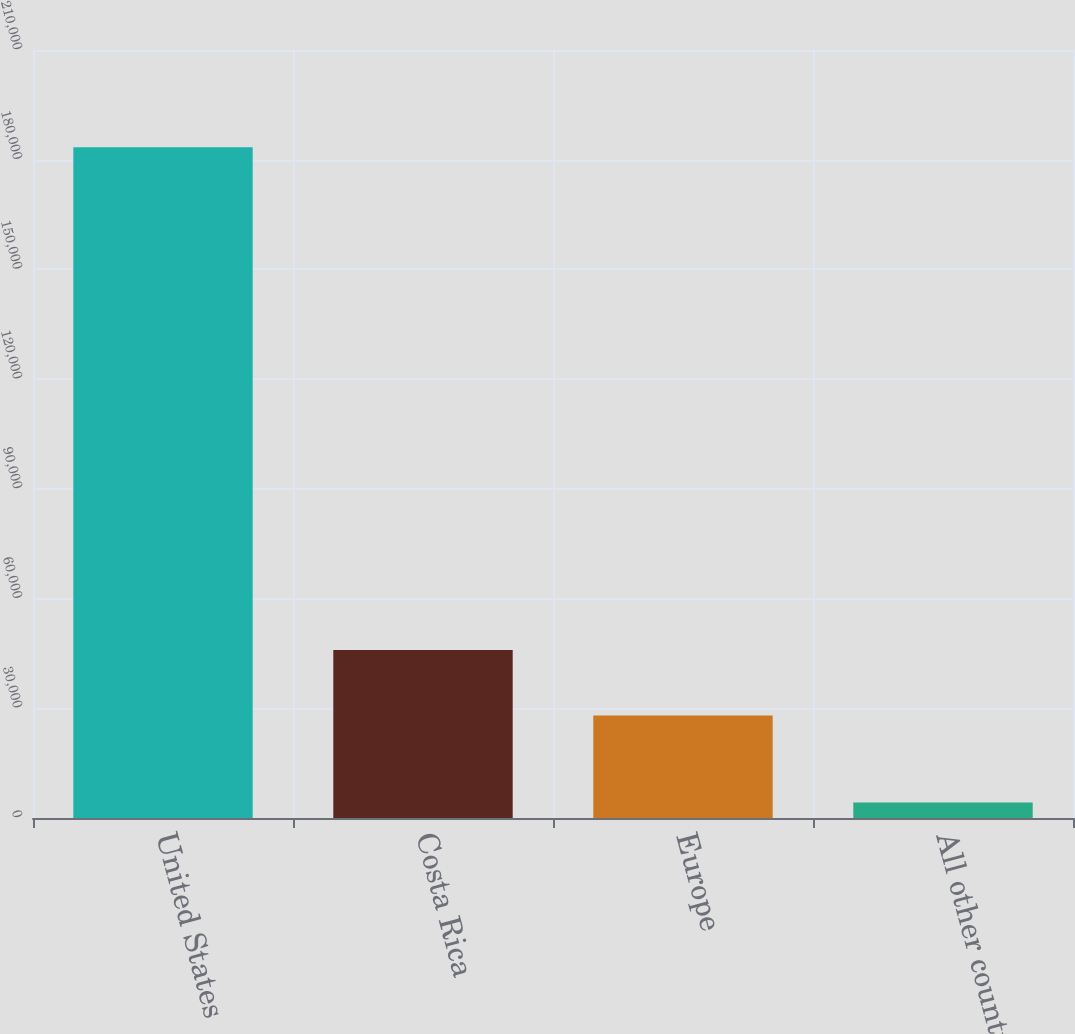Convert chart to OTSL. <chart><loc_0><loc_0><loc_500><loc_500><bar_chart><fcel>United States<fcel>Costa Rica<fcel>Europe<fcel>All other countries<nl><fcel>183383<fcel>45971.2<fcel>28060<fcel>4271<nl></chart> 